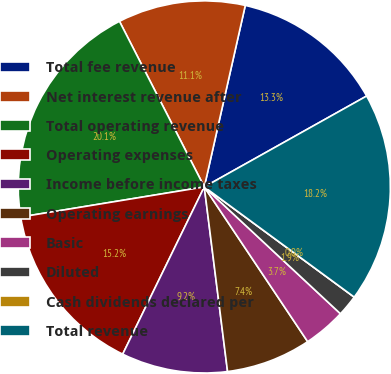<chart> <loc_0><loc_0><loc_500><loc_500><pie_chart><fcel>Total fee revenue<fcel>Net interest revenue after<fcel>Total operating revenue<fcel>Operating expenses<fcel>Income before income taxes<fcel>Operating earnings<fcel>Basic<fcel>Diluted<fcel>Cash dividends declared per<fcel>Total revenue<nl><fcel>13.34%<fcel>11.07%<fcel>20.05%<fcel>15.19%<fcel>9.22%<fcel>7.38%<fcel>3.69%<fcel>1.85%<fcel>0.0%<fcel>18.21%<nl></chart> 